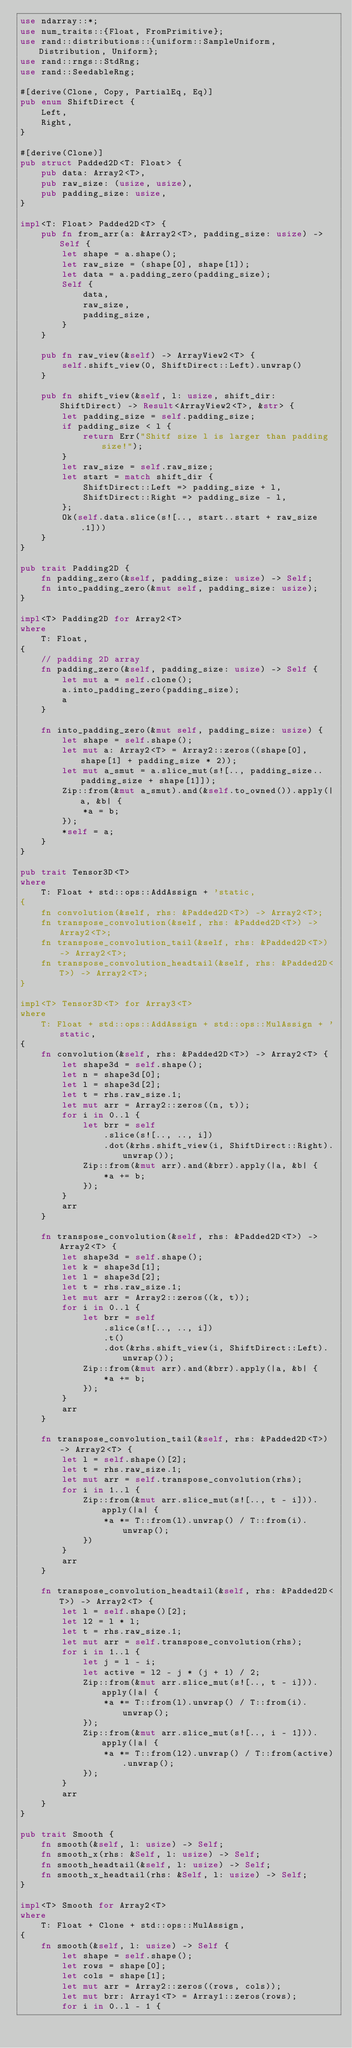Convert code to text. <code><loc_0><loc_0><loc_500><loc_500><_Rust_>use ndarray::*;
use num_traits::{Float, FromPrimitive};
use rand::distributions::{uniform::SampleUniform, Distribution, Uniform};
use rand::rngs::StdRng;
use rand::SeedableRng;

#[derive(Clone, Copy, PartialEq, Eq)]
pub enum ShiftDirect {
    Left,
    Right,
}

#[derive(Clone)]
pub struct Padded2D<T: Float> {
    pub data: Array2<T>,
    pub raw_size: (usize, usize),
    pub padding_size: usize,
}

impl<T: Float> Padded2D<T> {
    pub fn from_arr(a: &Array2<T>, padding_size: usize) -> Self {
        let shape = a.shape();
        let raw_size = (shape[0], shape[1]);
        let data = a.padding_zero(padding_size);
        Self {
            data,
            raw_size,
            padding_size,
        }
    }

    pub fn raw_view(&self) -> ArrayView2<T> {
        self.shift_view(0, ShiftDirect::Left).unwrap()
    }

    pub fn shift_view(&self, l: usize, shift_dir: ShiftDirect) -> Result<ArrayView2<T>, &str> {
        let padding_size = self.padding_size;
        if padding_size < l {
            return Err("Shitf size l is larger than padding size!");
        }
        let raw_size = self.raw_size;
        let start = match shift_dir {
            ShiftDirect::Left => padding_size + l,
            ShiftDirect::Right => padding_size - l,
        };
        Ok(self.data.slice(s![.., start..start + raw_size.1]))
    }
}

pub trait Padding2D {
    fn padding_zero(&self, padding_size: usize) -> Self;
    fn into_padding_zero(&mut self, padding_size: usize);
}

impl<T> Padding2D for Array2<T>
where
    T: Float,
{
    // padding 2D array
    fn padding_zero(&self, padding_size: usize) -> Self {
        let mut a = self.clone();
        a.into_padding_zero(padding_size);
        a
    }

    fn into_padding_zero(&mut self, padding_size: usize) {
        let shape = self.shape();
        let mut a: Array2<T> = Array2::zeros((shape[0], shape[1] + padding_size * 2));
        let mut a_smut = a.slice_mut(s![.., padding_size..padding_size + shape[1]]);
        Zip::from(&mut a_smut).and(&self.to_owned()).apply(|a, &b| {
            *a = b;
        });
        *self = a;
    }
}

pub trait Tensor3D<T>
where
    T: Float + std::ops::AddAssign + 'static,
{
    fn convolution(&self, rhs: &Padded2D<T>) -> Array2<T>;
    fn transpose_convolution(&self, rhs: &Padded2D<T>) -> Array2<T>;
    fn transpose_convolution_tail(&self, rhs: &Padded2D<T>) -> Array2<T>;
    fn transpose_convolution_headtail(&self, rhs: &Padded2D<T>) -> Array2<T>;
}

impl<T> Tensor3D<T> for Array3<T>
where
    T: Float + std::ops::AddAssign + std::ops::MulAssign + 'static,
{
    fn convolution(&self, rhs: &Padded2D<T>) -> Array2<T> {
        let shape3d = self.shape();
        let n = shape3d[0];
        let l = shape3d[2];
        let t = rhs.raw_size.1;
        let mut arr = Array2::zeros((n, t));
        for i in 0..l {
            let brr = self
                .slice(s![.., .., i])
                .dot(&rhs.shift_view(i, ShiftDirect::Right).unwrap());
            Zip::from(&mut arr).and(&brr).apply(|a, &b| {
                *a += b;
            });
        }
        arr
    }

    fn transpose_convolution(&self, rhs: &Padded2D<T>) -> Array2<T> {
        let shape3d = self.shape();
        let k = shape3d[1];
        let l = shape3d[2];
        let t = rhs.raw_size.1;
        let mut arr = Array2::zeros((k, t));
        for i in 0..l {
            let brr = self
                .slice(s![.., .., i])
                .t()
                .dot(&rhs.shift_view(i, ShiftDirect::Left).unwrap());
            Zip::from(&mut arr).and(&brr).apply(|a, &b| {
                *a += b;
            });
        }
        arr
    }

    fn transpose_convolution_tail(&self, rhs: &Padded2D<T>) -> Array2<T> {
        let l = self.shape()[2];
        let t = rhs.raw_size.1;
        let mut arr = self.transpose_convolution(rhs);
        for i in 1..l {
            Zip::from(&mut arr.slice_mut(s![.., t - i])).apply(|a| {
                *a *= T::from(l).unwrap() / T::from(i).unwrap();
            })
        }
        arr
    }

    fn transpose_convolution_headtail(&self, rhs: &Padded2D<T>) -> Array2<T> {
        let l = self.shape()[2];
        let l2 = l * l;
        let t = rhs.raw_size.1;
        let mut arr = self.transpose_convolution(rhs);
        for i in 1..l {
            let j = l - i;
            let active = l2 - j * (j + 1) / 2;
            Zip::from(&mut arr.slice_mut(s![.., t - i])).apply(|a| {
                *a *= T::from(l).unwrap() / T::from(i).unwrap();
            });
            Zip::from(&mut arr.slice_mut(s![.., i - 1])).apply(|a| {
                *a *= T::from(l2).unwrap() / T::from(active).unwrap();
            });
        }
        arr
    }
}

pub trait Smooth {
    fn smooth(&self, l: usize) -> Self;
    fn smooth_x(rhs: &Self, l: usize) -> Self;
    fn smooth_headtail(&self, l: usize) -> Self;
    fn smooth_x_headtail(rhs: &Self, l: usize) -> Self;
}

impl<T> Smooth for Array2<T>
where
    T: Float + Clone + std::ops::MulAssign,
{
    fn smooth(&self, l: usize) -> Self {
        let shape = self.shape();
        let rows = shape[0];
        let cols = shape[1];
        let mut arr = Array2::zeros((rows, cols));
        let mut brr: Array1<T> = Array1::zeros(rows);
        for i in 0..l - 1 {</code> 